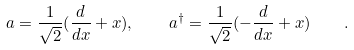Convert formula to latex. <formula><loc_0><loc_0><loc_500><loc_500>a = \frac { 1 } { \sqrt { 2 } } ( \frac { d } { d x } + x ) , \quad a ^ { \dagger } = \frac { 1 } { \sqrt { 2 } } ( - \frac { d } { d x } + x ) \quad .</formula> 